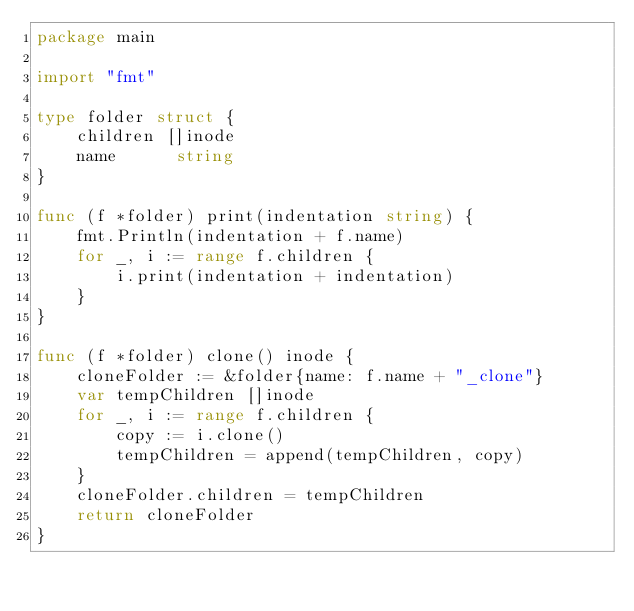Convert code to text. <code><loc_0><loc_0><loc_500><loc_500><_Go_>package main

import "fmt"

type folder struct {
	children []inode
	name      string
}

func (f *folder) print(indentation string) {
	fmt.Println(indentation + f.name)
	for _, i := range f.children {
		i.print(indentation + indentation)
	}
}

func (f *folder) clone() inode {
	cloneFolder := &folder{name: f.name + "_clone"}
	var tempChildren []inode
	for _, i := range f.children {
		copy := i.clone()
		tempChildren = append(tempChildren, copy)
	}
	cloneFolder.children = tempChildren
	return cloneFolder
}
</code> 